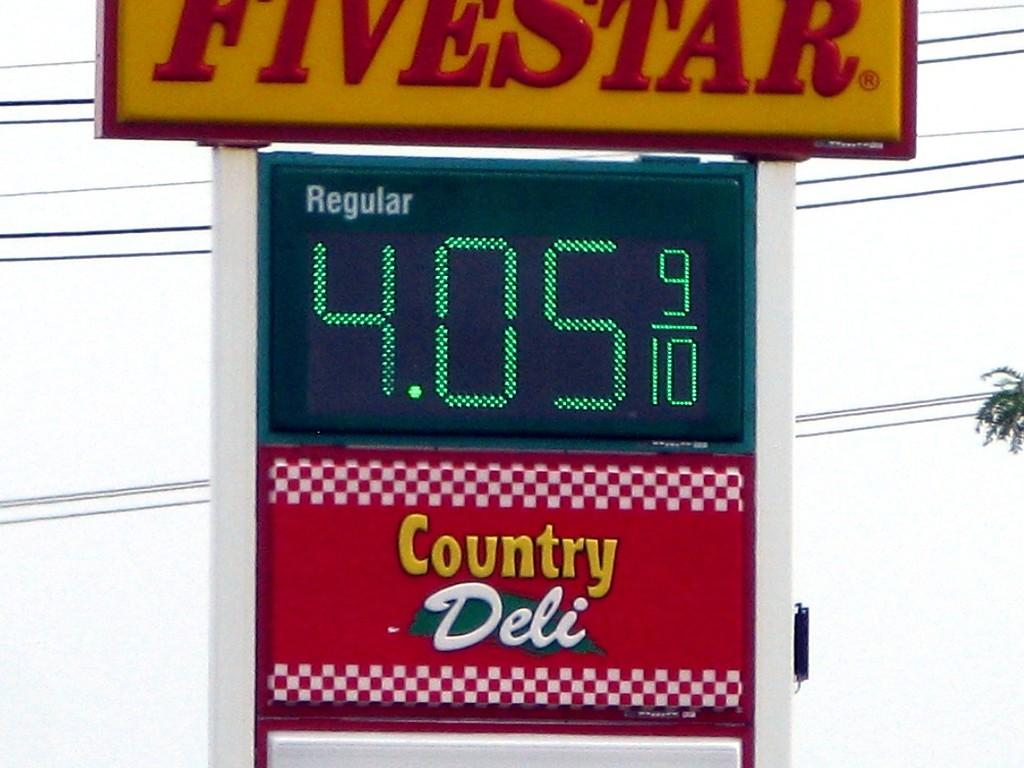<image>
Render a clear and concise summary of the photo. Yellow and red sign that says FiveStar on top of the price for gas. 